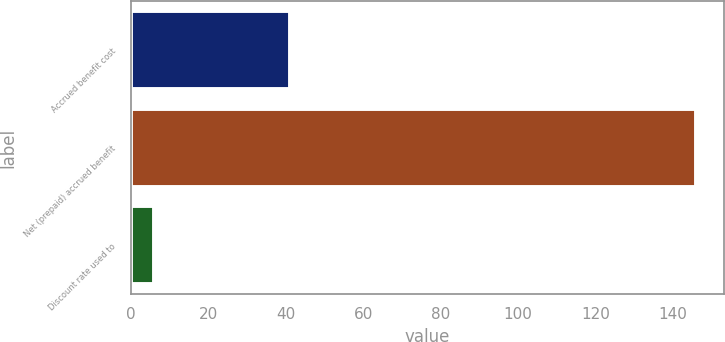Convert chart to OTSL. <chart><loc_0><loc_0><loc_500><loc_500><bar_chart><fcel>Accrued benefit cost<fcel>Net (prepaid) accrued benefit<fcel>Discount rate used to<nl><fcel>41<fcel>146<fcel>6<nl></chart> 